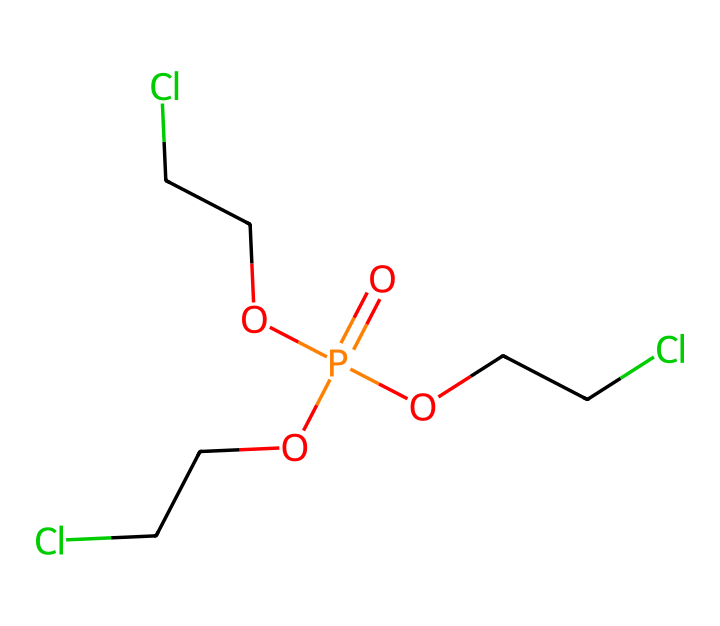What is the total number of phosphorus atoms in this compound? By analyzing the SMILES representation, there is one phosphorus (P) atom present in the center of the structure, surrounded by various hydroxyl and alkyl groups.
Answer: 1 How many chlorine (Cl) atoms are present in the chemical structure? The chemical shows three ethyl groups each containing one chlorine atom attached to the oxygen, resulting in a total of three chlorine (Cl) atoms.
Answer: 3 What type of chemical is represented by this structure? The presence of phosphorus, oxygen, and multiple alkyl chains indicates that this compound is a type of phosphate ester, specifically a flame retardant.
Answer: phosphate ester What functional groups can be identified in this compound? The compound consists of phosphate (-O=P(…)) groups and ether-like groups due to the ethyl chains attached to the oxygen atoms.
Answer: phosphate and ether How many oxygen atoms are present in this chemical? From the SMILES structure, there are four oxygen (O) atoms indicated; one oxo (double-bonded) and three in the ethyl chains.
Answer: 4 Why is phosphorus used in flame retardants for vehicle interiors? Phosphorus compounds are effective in flame retardants because they promote char formation and reduce flammability due to their unique chemical properties.
Answer: char formation What role do the ethyl groups play in this phosphorus compound? The ethyl groups (C2H5) enhance the hydrophobicity and volatility of the compound while also providing the necessary functional groups to interact with polymer matrices in vehicle interiors.
Answer: hydrophobicity 